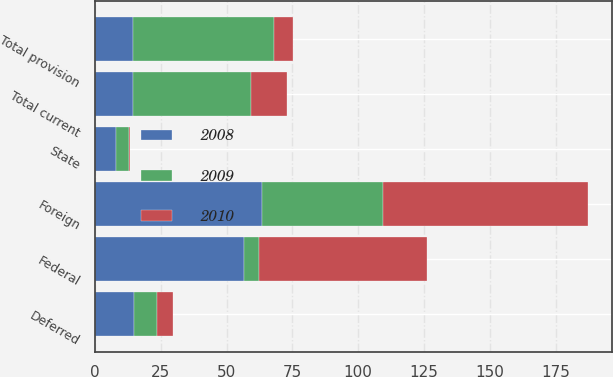Convert chart to OTSL. <chart><loc_0><loc_0><loc_500><loc_500><stacked_bar_chart><ecel><fcel>Federal<fcel>State<fcel>Foreign<fcel>Total current<fcel>Deferred<fcel>Total provision<nl><fcel>2010<fcel>63.6<fcel>0.5<fcel>77.7<fcel>13.6<fcel>6.1<fcel>7.5<nl><fcel>2008<fcel>56.4<fcel>8.1<fcel>63.3<fcel>14.25<fcel>14.9<fcel>14.25<nl><fcel>2009<fcel>6<fcel>4.7<fcel>46.2<fcel>44.9<fcel>8.7<fcel>53.6<nl></chart> 